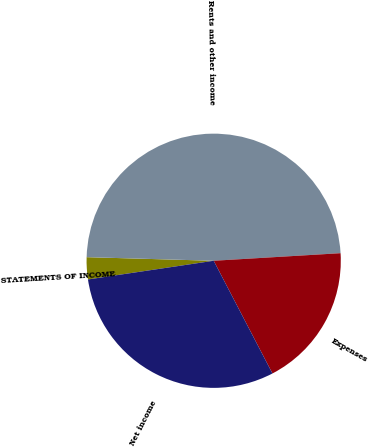<chart> <loc_0><loc_0><loc_500><loc_500><pie_chart><fcel>STATEMENTS OF INCOME<fcel>Rents and other income<fcel>Expenses<fcel>Net income<nl><fcel>2.8%<fcel>48.6%<fcel>18.3%<fcel>30.3%<nl></chart> 